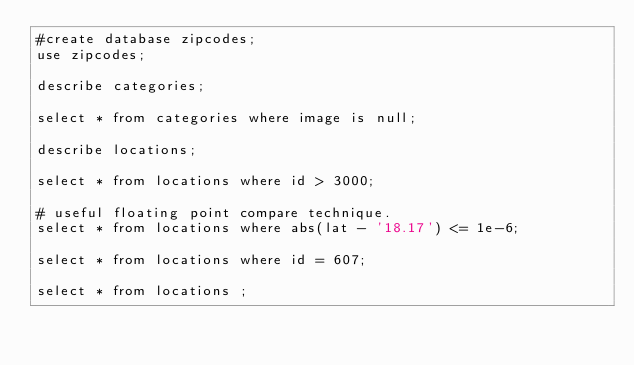Convert code to text. <code><loc_0><loc_0><loc_500><loc_500><_SQL_>#create database zipcodes;
use zipcodes;

describe categories;

select * from categories where image is null;

describe locations;

select * from locations where id > 3000;

# useful floating point compare technique.
select * from locations where abs(lat - '18.17') <= 1e-6;

select * from locations where id = 607;

select * from locations ;
</code> 